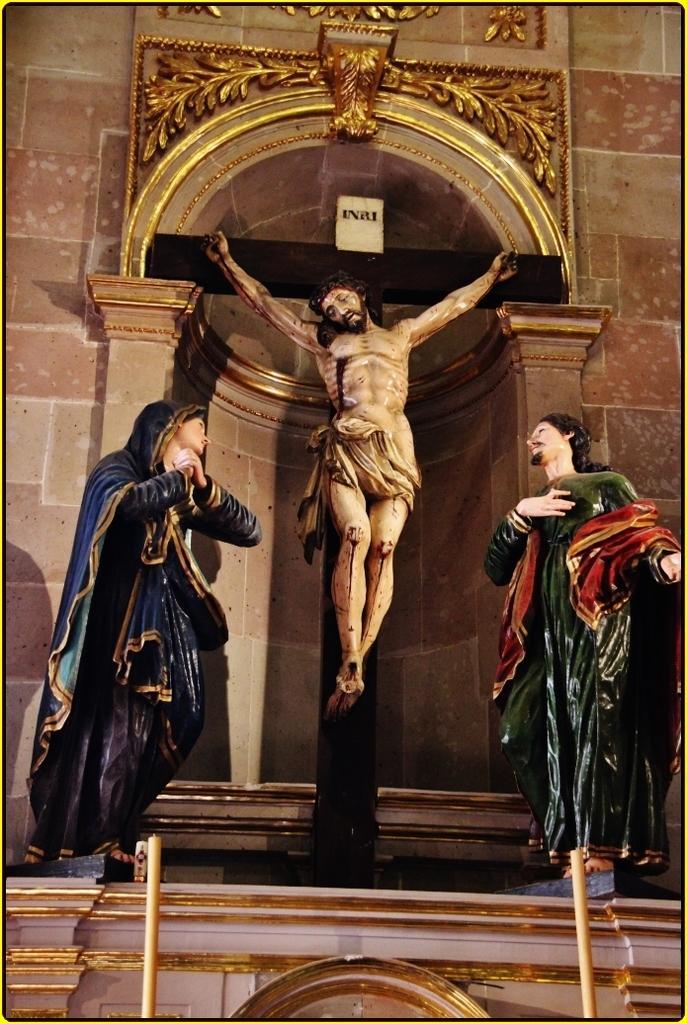Describe this image in one or two sentences. This picture contains sculptures, pillars and an arch. 